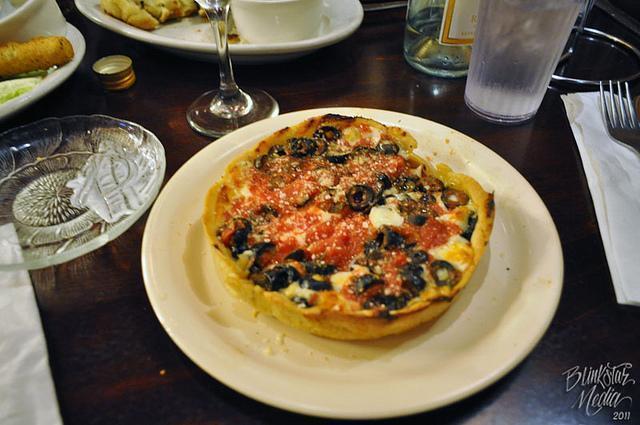What style of pizza is on the plate?
Make your selection from the four choices given to correctly answer the question.
Options: Deep dish, neapolitan, thin crust, stuffed crust. Deep dish. 